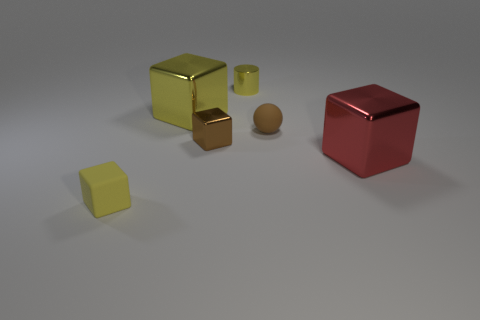Add 2 shiny cylinders. How many objects exist? 8 Subtract all balls. How many objects are left? 5 Subtract 1 cubes. How many cubes are left? 3 Subtract all red cylinders. Subtract all brown cubes. How many cylinders are left? 1 Subtract all blue cylinders. How many red cubes are left? 1 Subtract all brown blocks. Subtract all tiny yellow shiny objects. How many objects are left? 4 Add 6 red cubes. How many red cubes are left? 7 Add 4 yellow things. How many yellow things exist? 7 Subtract all yellow cubes. How many cubes are left? 2 Subtract all tiny metallic cubes. How many cubes are left? 3 